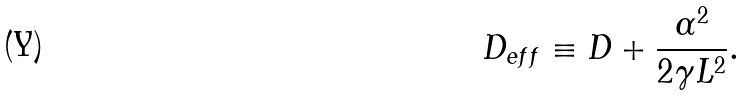<formula> <loc_0><loc_0><loc_500><loc_500>D _ { e f f } \equiv D + \frac { \alpha ^ { 2 } } { 2 \gamma L ^ { 2 } } .</formula> 